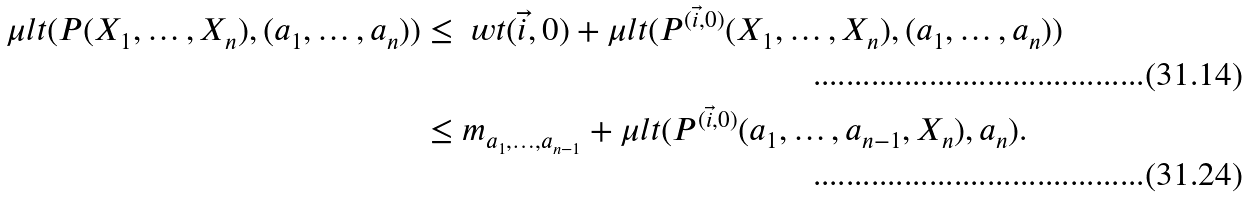<formula> <loc_0><loc_0><loc_500><loc_500>\mu l t ( P ( X _ { 1 } , \dots , X _ { n } ) , ( a _ { 1 } , \dots , a _ { n } ) ) & \leq \ w t ( \vec { i } , 0 ) + \mu l t ( P ^ { ( \vec { i } , 0 ) } ( X _ { 1 } , \dots , X _ { n } ) , ( a _ { 1 } , \dots , a _ { n } ) ) \\ & \leq m _ { a _ { 1 } , \dots , a _ { n - 1 } } + \mu l t ( P ^ { ( \vec { i } , 0 ) } ( a _ { 1 } , \dots , a _ { n - 1 } , X _ { n } ) , a _ { n } ) .</formula> 